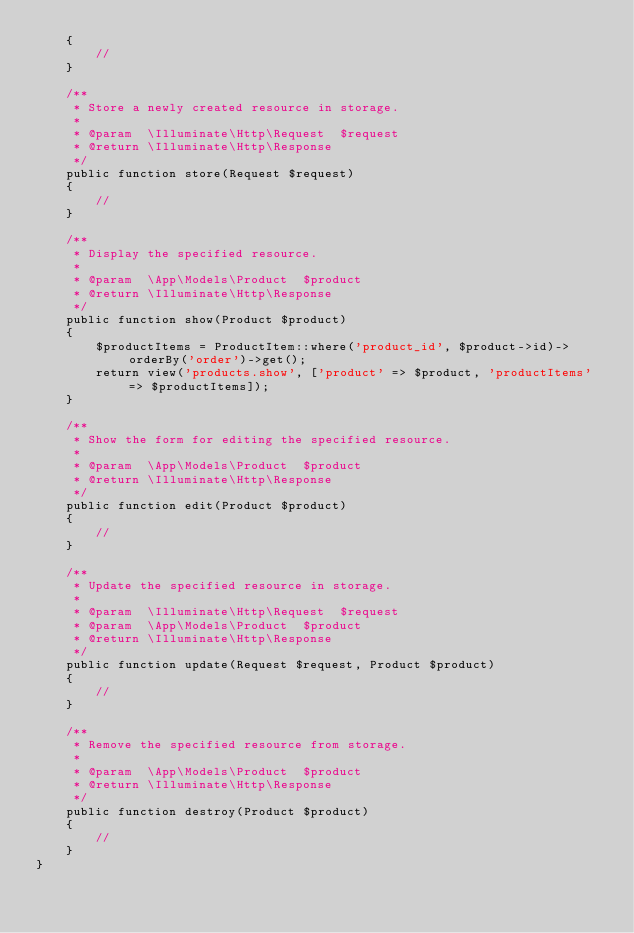<code> <loc_0><loc_0><loc_500><loc_500><_PHP_>    {
        //
    }

    /**
     * Store a newly created resource in storage.
     *
     * @param  \Illuminate\Http\Request  $request
     * @return \Illuminate\Http\Response
     */
    public function store(Request $request)
    {
        //
    }

    /**
     * Display the specified resource.
     *
     * @param  \App\Models\Product  $product
     * @return \Illuminate\Http\Response
     */
    public function show(Product $product)
    {
        $productItems = ProductItem::where('product_id', $product->id)->orderBy('order')->get();
        return view('products.show', ['product' => $product, 'productItems' => $productItems]);
    }

    /**
     * Show the form for editing the specified resource.
     *
     * @param  \App\Models\Product  $product
     * @return \Illuminate\Http\Response
     */
    public function edit(Product $product)
    {
        //
    }

    /**
     * Update the specified resource in storage.
     *
     * @param  \Illuminate\Http\Request  $request
     * @param  \App\Models\Product  $product
     * @return \Illuminate\Http\Response
     */
    public function update(Request $request, Product $product)
    {
        //
    }

    /**
     * Remove the specified resource from storage.
     *
     * @param  \App\Models\Product  $product
     * @return \Illuminate\Http\Response
     */
    public function destroy(Product $product)
    {
        //
    }
}</code> 